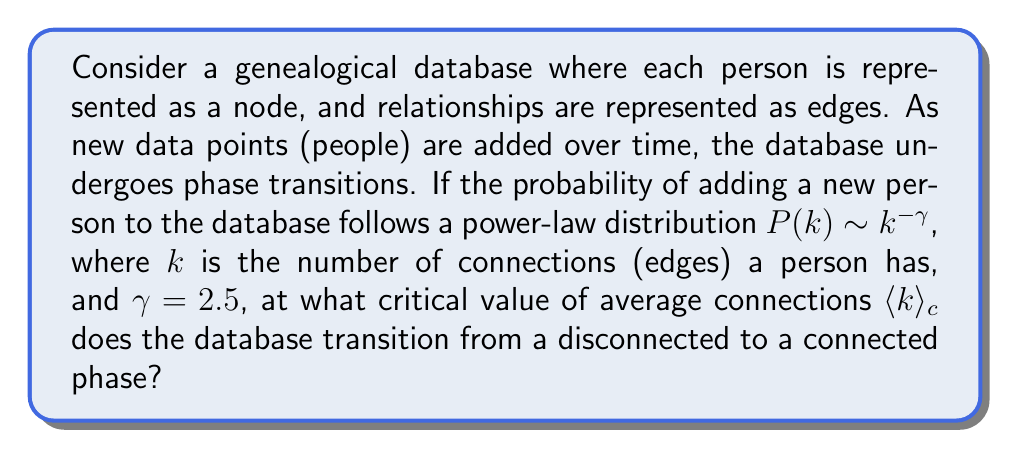Help me with this question. To solve this problem, we'll use concepts from statistical mechanics and network theory:

1) In scale-free networks (which follow power-law distributions), the critical point for the phase transition from disconnected to connected occurs when:

   $$\frac{\langle k^2 \rangle}{\langle k \rangle} = 2$$

2) For a power-law distribution $P(k) \sim k^{-\gamma}$, we can calculate moments:

   $$\langle k^n \rangle = \frac{\int_{k_{min}}^{k_{max}} k^n k^{-\gamma} dk}{\int_{k_{min}}^{k_{max}} k^{-\gamma} dk}$$

3) Assuming $k_{max} \gg k_{min}$, for $\gamma > 2$:

   $$\langle k \rangle \approx \frac{\gamma - 1}{\gamma - 2} k_{min}$$
   $$\langle k^2 \rangle \approx \frac{\gamma - 1}{\gamma - 3} k_{min}^2$$

4) Substituting these into the critical condition:

   $$\frac{\langle k^2 \rangle}{\langle k \rangle} = \frac{\frac{\gamma - 1}{\gamma - 3} k_{min}^2}{\frac{\gamma - 1}{\gamma - 2} k_{min}} = 2$$

5) Simplifying:

   $$\frac{\gamma - 2}{\gamma - 3} k_{min} = 2$$

6) For $\gamma = 2.5$:

   $$\frac{0.5}{-0.5} k_{min} = 2$$
   $$k_{min} = 2$$

7) Therefore, the critical average degree is:

   $$\langle k \rangle_c = \frac{\gamma - 1}{\gamma - 2} k_{min} = \frac{1.5}{0.5} \cdot 2 = 6$$
Answer: 6 